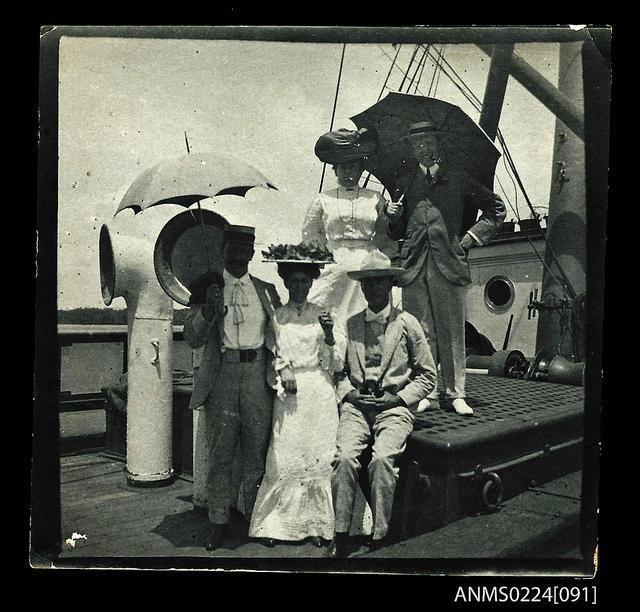How many people are wearing hats?
Give a very brief answer. 5. How many people are there?
Give a very brief answer. 5. How many umbrellas can you see?
Give a very brief answer. 2. 